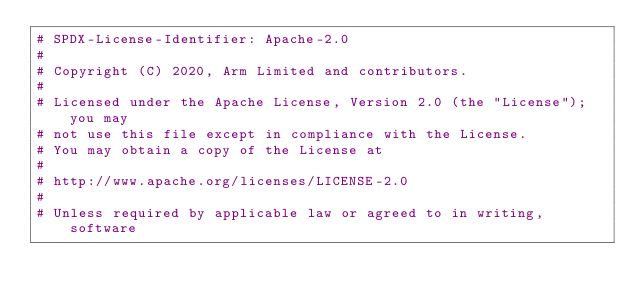Convert code to text. <code><loc_0><loc_0><loc_500><loc_500><_Python_># SPDX-License-Identifier: Apache-2.0
#
# Copyright (C) 2020, Arm Limited and contributors.
#
# Licensed under the Apache License, Version 2.0 (the "License"); you may
# not use this file except in compliance with the License.
# You may obtain a copy of the License at
#
# http://www.apache.org/licenses/LICENSE-2.0
#
# Unless required by applicable law or agreed to in writing, software</code> 